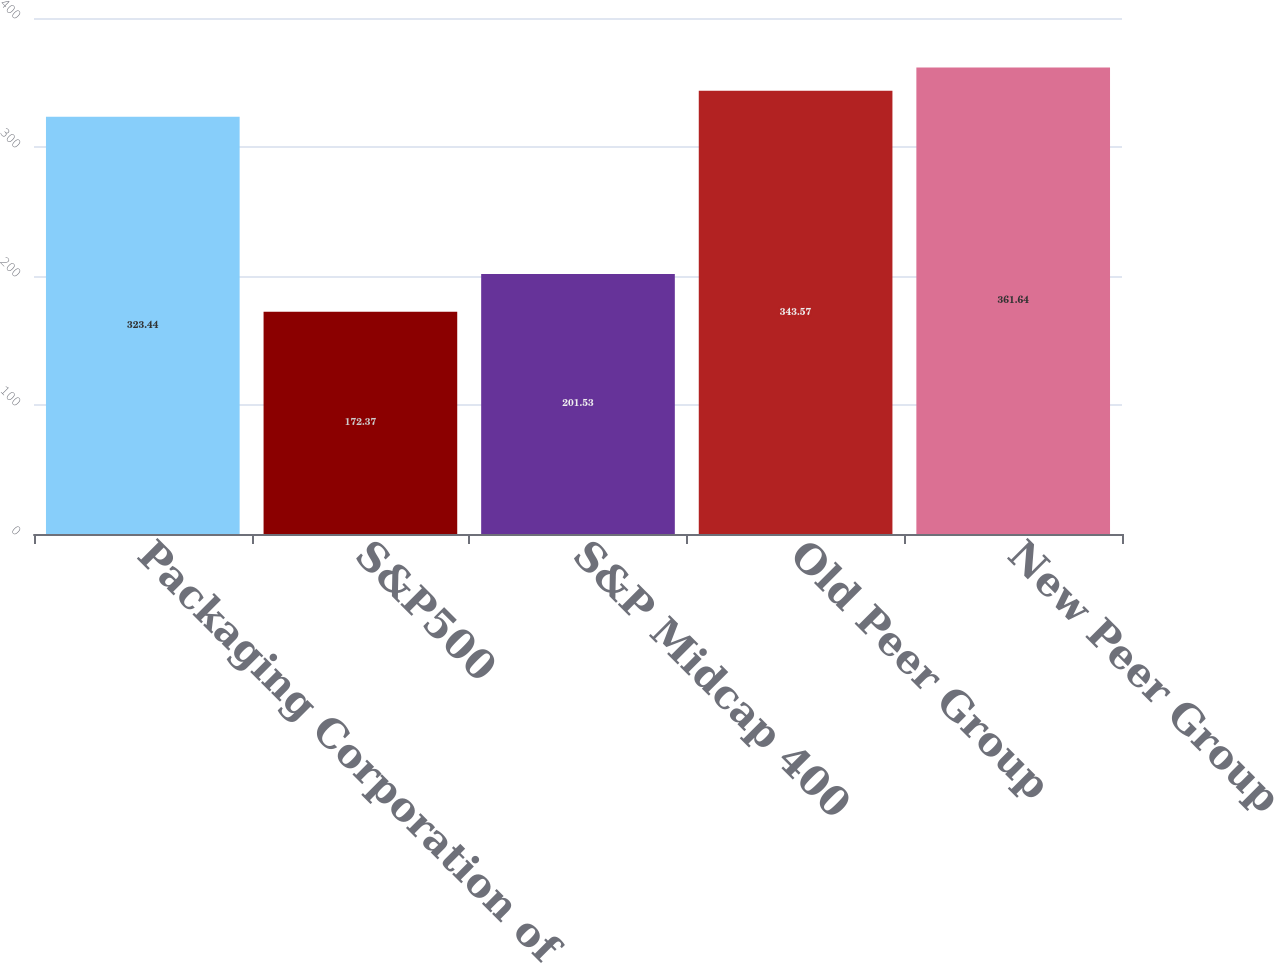<chart> <loc_0><loc_0><loc_500><loc_500><bar_chart><fcel>Packaging Corporation of<fcel>S&P500<fcel>S&P Midcap 400<fcel>Old Peer Group<fcel>New Peer Group<nl><fcel>323.44<fcel>172.37<fcel>201.53<fcel>343.57<fcel>361.64<nl></chart> 